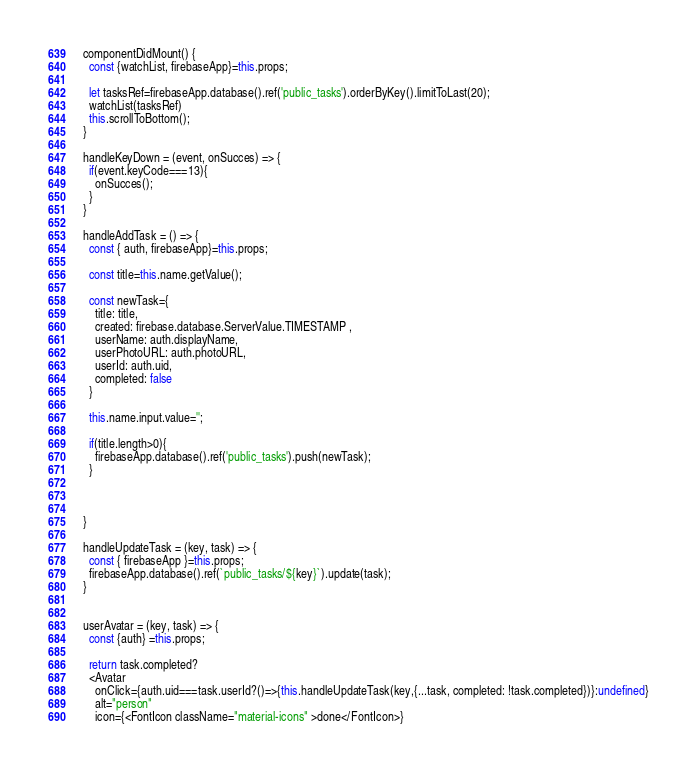Convert code to text. <code><loc_0><loc_0><loc_500><loc_500><_JavaScript_>
  componentDidMount() {
    const {watchList, firebaseApp}=this.props;

    let tasksRef=firebaseApp.database().ref('public_tasks').orderByKey().limitToLast(20);
    watchList(tasksRef)
    this.scrollToBottom();
  }

  handleKeyDown = (event, onSucces) => {
    if(event.keyCode===13){
      onSucces();
    }
  }

  handleAddTask = () => {
    const { auth, firebaseApp}=this.props;

    const title=this.name.getValue();

    const newTask={
      title: title,
      created: firebase.database.ServerValue.TIMESTAMP ,
      userName: auth.displayName,
      userPhotoURL: auth.photoURL,
      userId: auth.uid,
      completed: false
    }

    this.name.input.value='';

    if(title.length>0){
      firebaseApp.database().ref('public_tasks').push(newTask);
    }



  }

  handleUpdateTask = (key, task) => {
    const { firebaseApp }=this.props;
    firebaseApp.database().ref(`public_tasks/${key}`).update(task);
  }


  userAvatar = (key, task) => {
    const {auth} =this.props;

    return task.completed?
    <Avatar
      onClick={auth.uid===task.userId?()=>{this.handleUpdateTask(key,{...task, completed: !task.completed})}:undefined}
      alt="person"
      icon={<FontIcon className="material-icons" >done</FontIcon>}</code> 